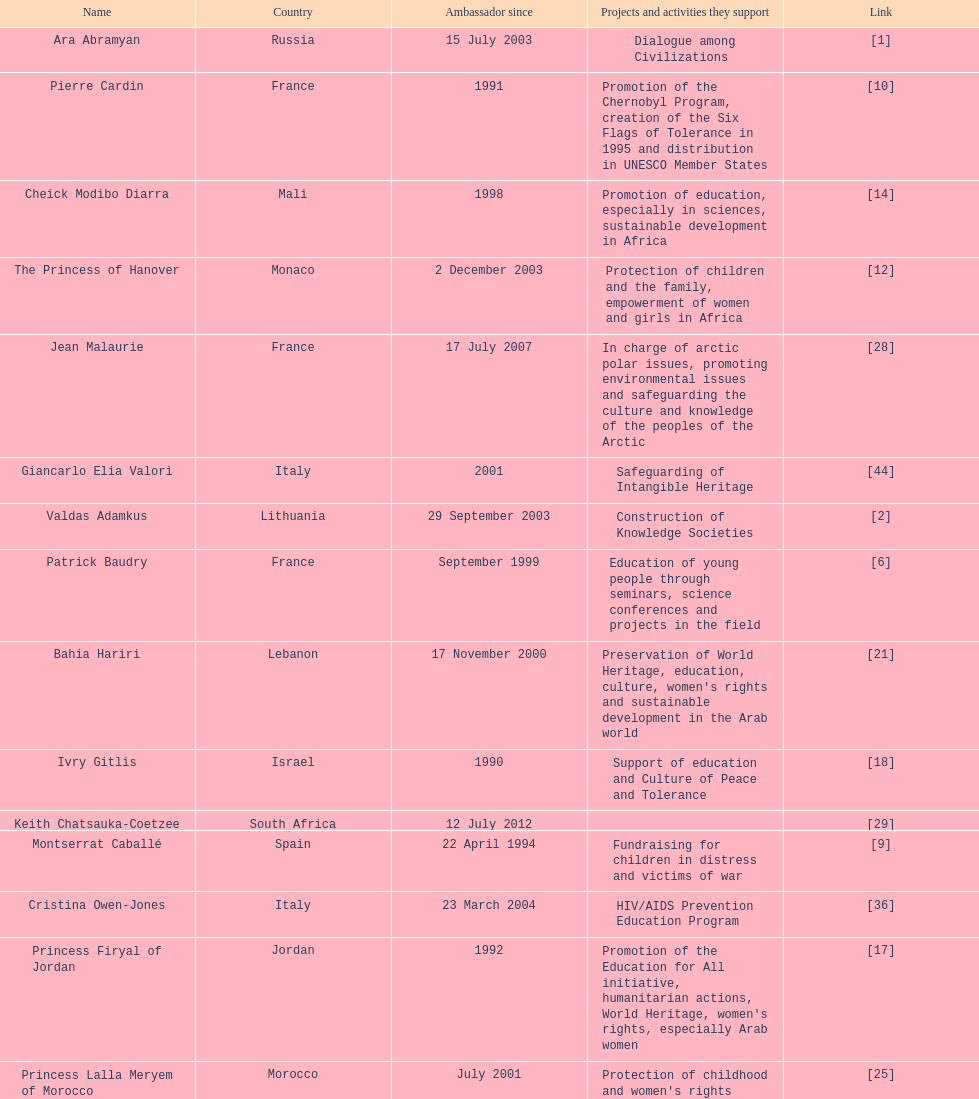Can you parse all the data within this table? {'header': ['Name', 'Country', 'Ambassador since', 'Projects and activities they support', 'Link'], 'rows': [['Ara Abramyan', 'Russia', '15 July 2003', 'Dialogue among Civilizations', '[1]'], ['Pierre Cardin', 'France', '1991', 'Promotion of the Chernobyl Program, creation of the Six Flags of Tolerance in 1995 and distribution in UNESCO Member States', '[10]'], ['Cheick Modibo Diarra', 'Mali', '1998', 'Promotion of education, especially in sciences, sustainable development in Africa', '[14]'], ['The Princess of Hanover', 'Monaco', '2 December 2003', 'Protection of children and the family, empowerment of women and girls in Africa', '[12]'], ['Jean Malaurie', 'France', '17 July 2007', 'In charge of arctic polar issues, promoting environmental issues and safeguarding the culture and knowledge of the peoples of the Arctic', '[28]'], ['Giancarlo Elia Valori', 'Italy', '2001', 'Safeguarding of Intangible Heritage', '[44]'], ['Valdas Adamkus', 'Lithuania', '29 September 2003', 'Construction of Knowledge Societies', '[2]'], ['Patrick Baudry', 'France', 'September 1999', 'Education of young people through seminars, science conferences and projects in the field', '[6]'], ['Bahia Hariri', 'Lebanon', '17 November 2000', "Preservation of World Heritage, education, culture, women's rights and sustainable development in the Arab world", '[21]'], ['Ivry Gitlis', 'Israel', '1990', 'Support of education and Culture of Peace and Tolerance', '[18]'], ['Keith Chatsauka-Coetzee', 'South Africa', '12 July 2012', '', '[29]'], ['Montserrat Caballé', 'Spain', '22 April 1994', 'Fundraising for children in distress and victims of war', '[9]'], ['Cristina Owen-Jones', 'Italy', '23 March 2004', 'HIV/AIDS Prevention Education Program', '[36]'], ['Princess Firyal of Jordan', 'Jordan', '1992', "Promotion of the Education for All initiative, humanitarian actions, World Heritage, women's rights, especially Arab women", '[17]'], ['Princess Lalla Meryem of Morocco', 'Morocco', 'July 2001', "Protection of childhood and women's rights", '[25]'], ['Christine Hakim', 'Indonesia', '11 March 2008', 'Teacher education in South East Asia', '[20]'], ['Mehriban Aliyeva', 'Azerbaijan', '9 September 2004', 'Promotion and safeguarding of intangible cultural heritage, especially oral traditions and expressions', '[3]'], ['Marc Ladreit de Lacharrière', 'France', '27 August 2009', '', '[24]'], ['Princess Maha Chakri Sirindhorn of Thailand', 'Thailand', '24 March 2005', 'Empowerment of Minority Children and the Preservation of their Intangible Cultural Heritage', '[27]'], ['Alicia Alonso', 'Cuba', '7 June 2002', 'Promotion of ballet dancing (Programme of Intangible Heritage)', '[4]'], ['Madanjeet Singh', 'India', '16 November 2000', 'Founder of the South Asia Foundation, which promotes regional cooperation through education and sustainable development', '[42]'], ['Nizan Guanaes', 'Brazil', '27 May 2011', '', '[19]'], ['Ivonne A-Baki', 'Ecuador', '15 February 2010', 'Peace', '[5]'], ['Vitaly Ignatenko', 'Russia', '2008', 'Building of the capacities of the Russian language journalists and promotion of the free circulation of ideas in the Russian-speaking world', '[22]'], ['Sunny Varkey', 'India', '', 'Promoter of education', '[48]'], ['Rigoberta Menchu Túm', 'Guatemala', '21 June 1996', 'Promotion of Culture of Peace, protection of rights of indigenous people', '[31]'], ['Laura Welch Bush', 'United States', '13 February 2003', 'UNESCO Honorary Ambassador for the Decade of Literacy in the context of the United Nations Literacy Decade (2003–2012)', '[49]'], ['Ute-Henriette Ohoven', 'Germany', '1992', 'UNESCO Special Ambassador for Education of Children in Need', '[35]'], ['Pierre Bergé', 'France', '2 July 1993', 'Campaign against HIV/AIDS, human rights, Cultural Heritage', '[7]'], ['Hayat Sindi', 'Saudi Arabia', '1 October 2012', 'Promotion of science education for Arab women', '[41]'], ['Omer Zülfü Livaneli', 'Turkey', '20 September 1996', 'Promotion of peace and polerance through music and promotion of human rights', '[26]'], ['Milú Villela', 'Brazil', '10 November 2004', 'Voluntary Action and Basic Education in Latin America', '[46]'], ['Claudia Cardinale', 'Italy', 'March 2000', "Promotion of women's rights, especially for women in the Mediterranean; Environment issues", '[11]'], ['Chantal Biya', 'Cameroon', '14 November 2008', 'Education and Social Inclusion', '[8]'], ['Miguel Angel Estrella', 'Argentina', '26 October 1989', 'Promotion of Culture of Peace and tolerance through music', '[15]'], ['Susana Rinaldi', 'Argentina', '28 April 1992', 'Street children, Culture of Peace', '[38]'], ['Kim Phuc Phan Thi', 'Vietnam', '10 November 1994', 'Protection and education for children, orphans and innocent victims of war', '[37]'], ['Yazid Sabeg', 'Algeria', '16 February 2010', '', '[39]'], ['Vigdís Finnbogadóttir', 'Iceland', '1998', "Promotion of linguistic diversity, women's rights, education", '[16]'], ['Oskar Metsavaht', 'Brazil', '27 May 2011', '', '[32]'], ['Zurab Tsereteli', 'Georgia', '30 March 1996', 'Cultural and artistic projects', '[43]'], ['Forest Whitaker', 'United States', '', '', '[47]'], ['Marianna Vardinoyannis', 'Greece', '21 October 1999', 'Protection of childhood; promotion of cultural olympics; humanitarian relief for war victims', '[45]'], ['Kitín Muñoz', 'Spain', '22 April 1997', 'Protection and promotion of indigenous cultures and their environment', '[34]'], ['Esther Coopersmith', 'United States', '', '', '[13]'], ['Grand Duchess María Teresa of Luxembourg', 'Luxembourg', '10 June 1997', "Education, Women's rights, microfinance and campaign against poverty", '[30]'], ['Jean Michel Jarre', 'France', '24 May 1993', 'Protection of the environment (water, fight against desertification, renewable energies), youth and tolerance, safeguarding of World Heritage', '[23]'], ['Vik Muniz', 'Brazil', '27 May 2011', '', '[33]'], ['Sheikh Ghassan I. Shaker', 'Saudi Arabia', '1989', 'Fundraising, children and women in need, victims of war, education, microfinance', '[40]']]} Which unesco goodwill ambassador is most known for the promotion of the chernobyl program? Pierre Cardin. 